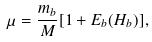<formula> <loc_0><loc_0><loc_500><loc_500>\mu = \frac { m _ { b } } { M } [ 1 + E _ { b } ( H _ { b } ) ] ,</formula> 